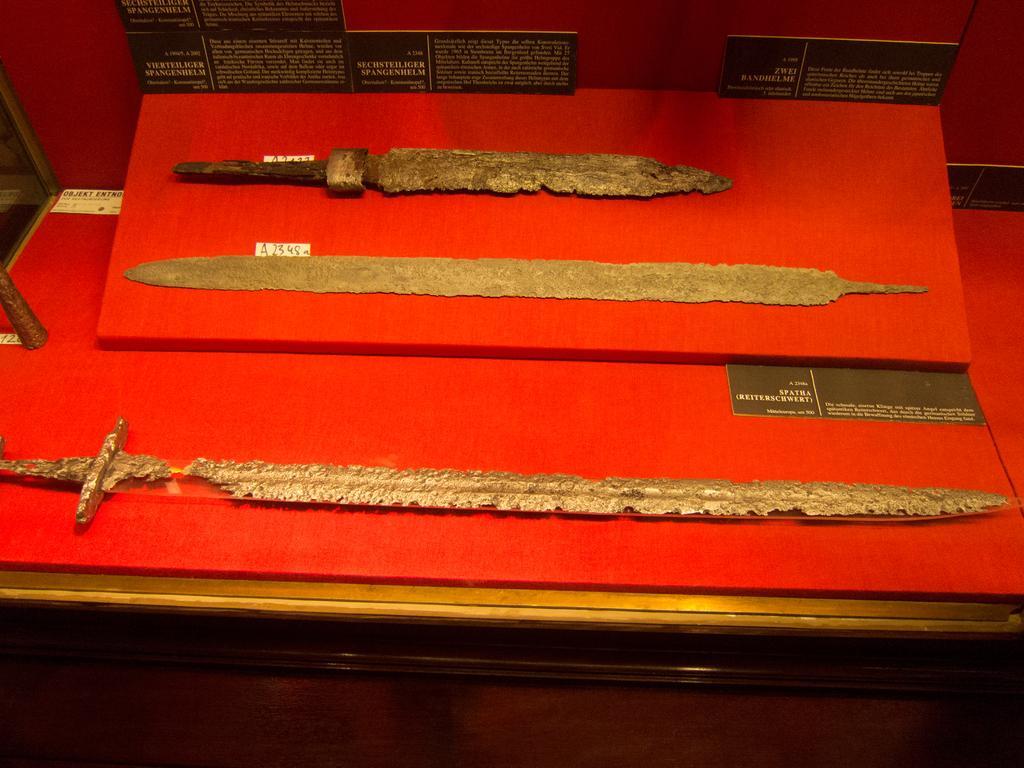Please provide a concise description of this image. In the image there are three ancient objects kept on a red surface and there is some information mentioned on the black cards around those objects. 